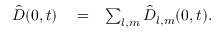Convert formula to latex. <formula><loc_0><loc_0><loc_500><loc_500>\begin{array} { r l r } { { \hat { \boldsymbol D } } ( \boldsymbol 0 , t ) } & = } & { \sum _ { l , m } { \hat { \boldsymbol D } } _ { l , m } ( \boldsymbol 0 , t ) . } \end{array}</formula> 